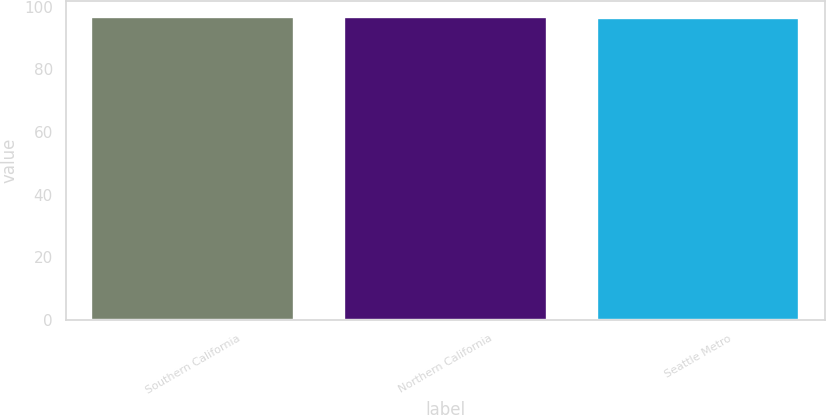Convert chart to OTSL. <chart><loc_0><loc_0><loc_500><loc_500><bar_chart><fcel>Southern California<fcel>Northern California<fcel>Seattle Metro<nl><fcel>96.6<fcel>96.8<fcel>96.4<nl></chart> 